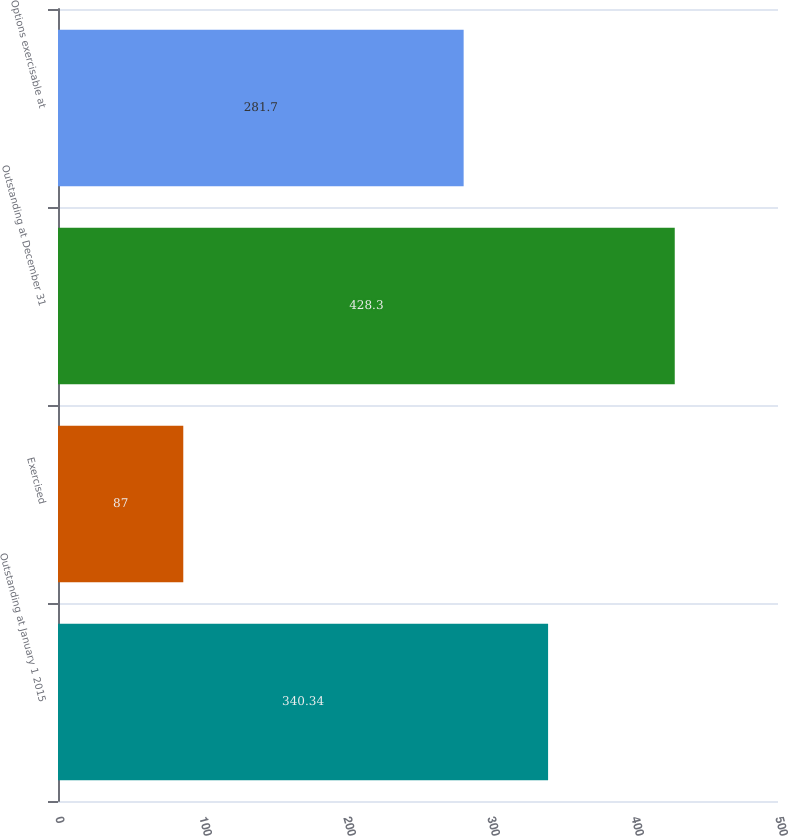Convert chart to OTSL. <chart><loc_0><loc_0><loc_500><loc_500><bar_chart><fcel>Outstanding at January 1 2015<fcel>Exercised<fcel>Outstanding at December 31<fcel>Options exercisable at<nl><fcel>340.34<fcel>87<fcel>428.3<fcel>281.7<nl></chart> 